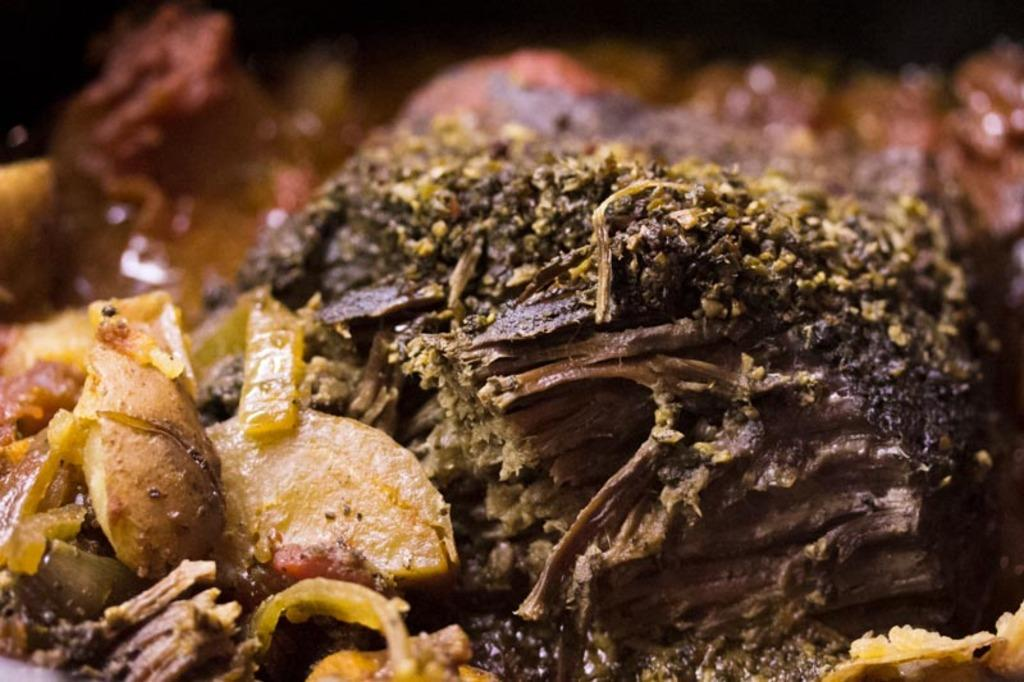What type of food items can be seen in the image? There are potato food items and onions in the image. Can you describe any other food items present in the image? There are other unspecified food items in the image. What type of class is being held in the image? There is no class or any indication of a class being held in the image. What type of iron is visible in the image? There is no iron present in the image. 